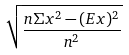<formula> <loc_0><loc_0><loc_500><loc_500>\sqrt { \frac { n \Sigma x ^ { 2 } - ( E x ) ^ { 2 } } { n ^ { 2 } } }</formula> 